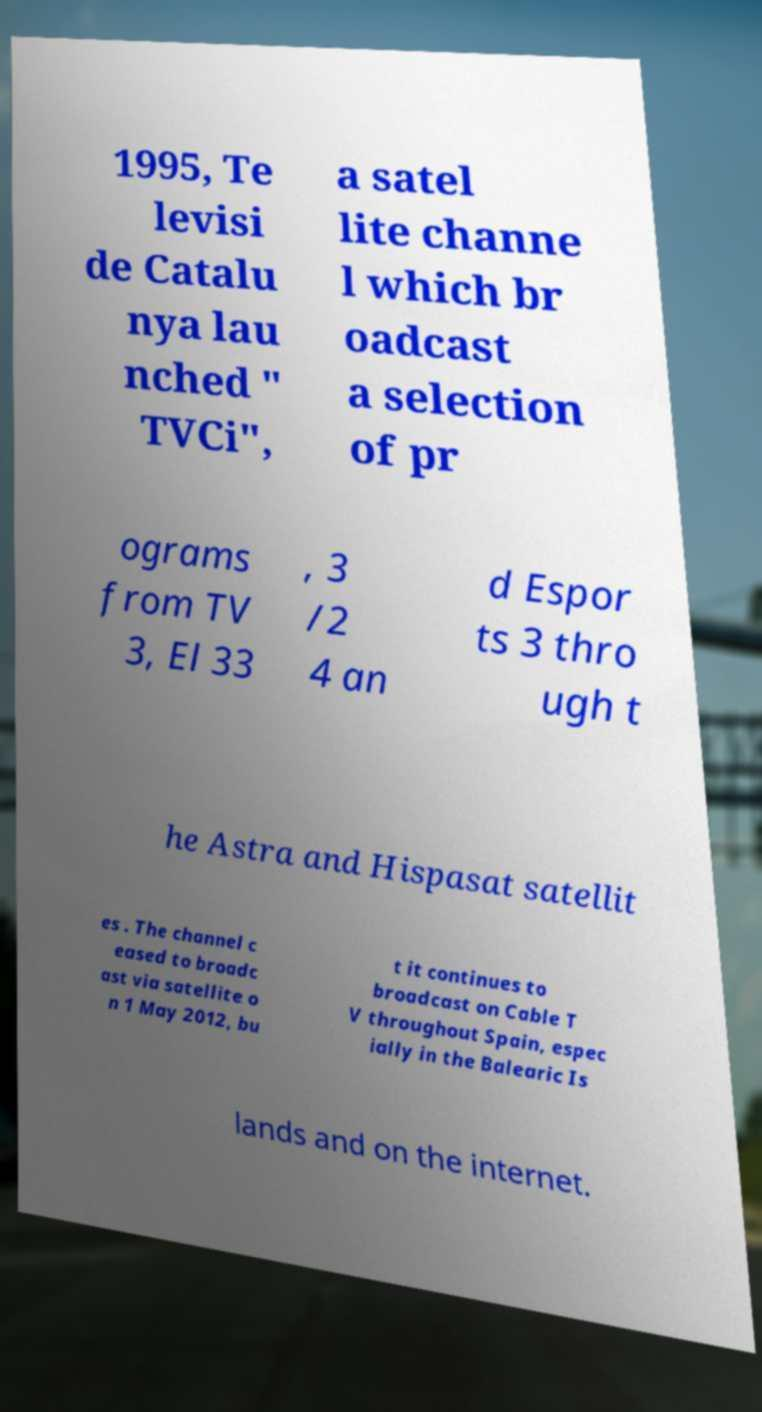Please read and relay the text visible in this image. What does it say? 1995, Te levisi de Catalu nya lau nched " TVCi", a satel lite channe l which br oadcast a selection of pr ograms from TV 3, El 33 , 3 /2 4 an d Espor ts 3 thro ugh t he Astra and Hispasat satellit es . The channel c eased to broadc ast via satellite o n 1 May 2012, bu t it continues to broadcast on Cable T V throughout Spain, espec ially in the Balearic Is lands and on the internet. 